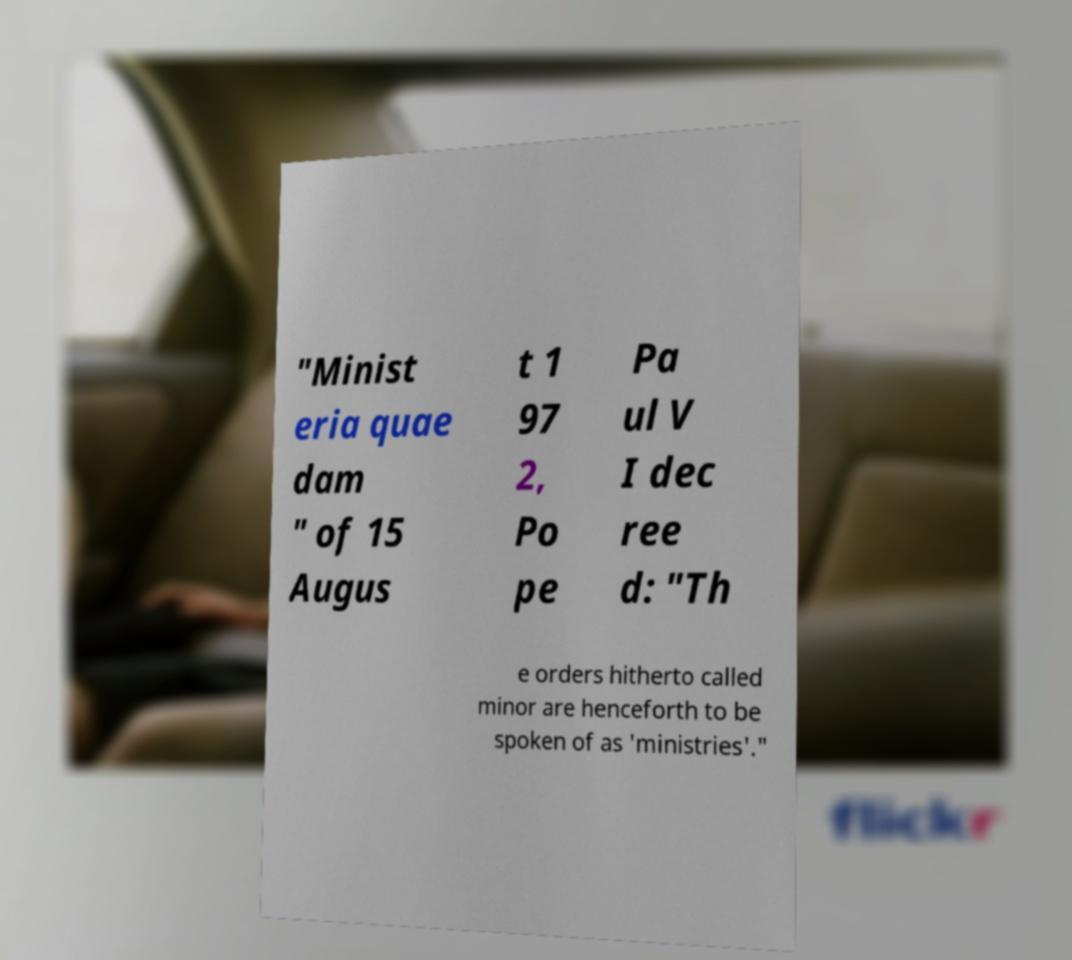Can you accurately transcribe the text from the provided image for me? "Minist eria quae dam " of 15 Augus t 1 97 2, Po pe Pa ul V I dec ree d: "Th e orders hitherto called minor are henceforth to be spoken of as 'ministries'." 